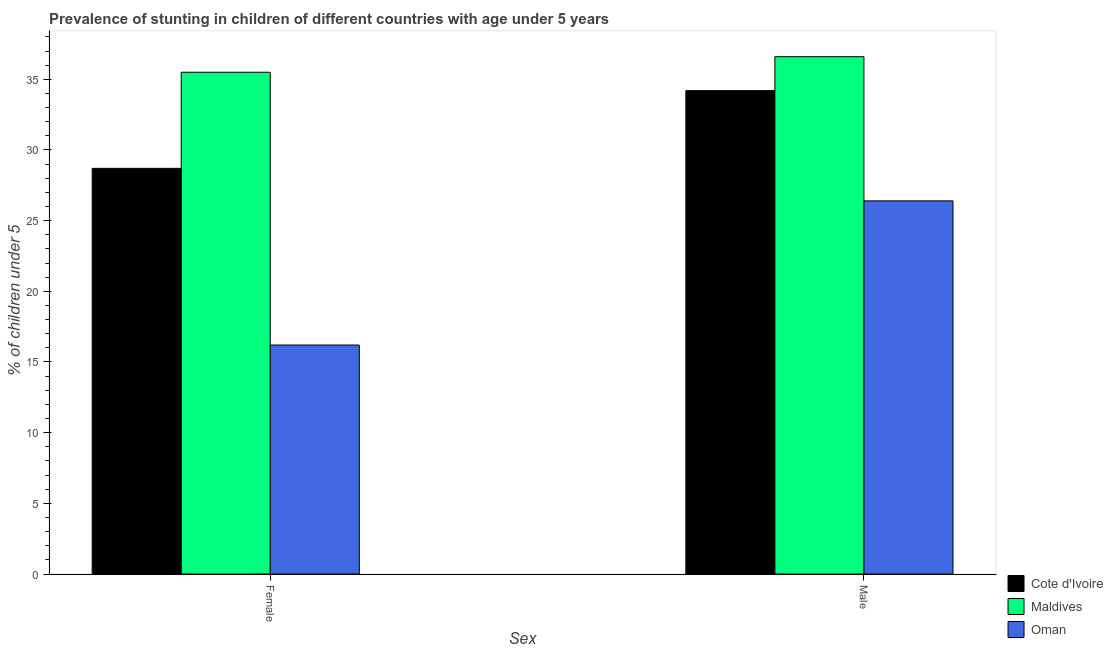How many different coloured bars are there?
Your response must be concise. 3. What is the label of the 2nd group of bars from the left?
Keep it short and to the point. Male. What is the percentage of stunted female children in Cote d'Ivoire?
Offer a terse response. 28.7. Across all countries, what is the maximum percentage of stunted male children?
Your answer should be compact. 36.6. Across all countries, what is the minimum percentage of stunted female children?
Your answer should be compact. 16.2. In which country was the percentage of stunted male children maximum?
Provide a short and direct response. Maldives. In which country was the percentage of stunted female children minimum?
Offer a terse response. Oman. What is the total percentage of stunted male children in the graph?
Your answer should be very brief. 97.2. What is the difference between the percentage of stunted male children in Oman and that in Maldives?
Provide a succinct answer. -10.2. What is the difference between the percentage of stunted male children in Maldives and the percentage of stunted female children in Oman?
Your response must be concise. 20.4. What is the average percentage of stunted female children per country?
Keep it short and to the point. 26.8. What is the difference between the percentage of stunted male children and percentage of stunted female children in Cote d'Ivoire?
Offer a very short reply. 5.5. In how many countries, is the percentage of stunted male children greater than 18 %?
Make the answer very short. 3. What is the ratio of the percentage of stunted male children in Maldives to that in Oman?
Ensure brevity in your answer.  1.39. Is the percentage of stunted female children in Cote d'Ivoire less than that in Maldives?
Make the answer very short. Yes. In how many countries, is the percentage of stunted male children greater than the average percentage of stunted male children taken over all countries?
Ensure brevity in your answer.  2. What does the 2nd bar from the left in Male represents?
Offer a very short reply. Maldives. What does the 1st bar from the right in Female represents?
Offer a very short reply. Oman. How many bars are there?
Your answer should be compact. 6. What is the difference between two consecutive major ticks on the Y-axis?
Your answer should be compact. 5. What is the title of the graph?
Give a very brief answer. Prevalence of stunting in children of different countries with age under 5 years. Does "Libya" appear as one of the legend labels in the graph?
Your answer should be very brief. No. What is the label or title of the X-axis?
Give a very brief answer. Sex. What is the label or title of the Y-axis?
Offer a terse response.  % of children under 5. What is the  % of children under 5 of Cote d'Ivoire in Female?
Offer a terse response. 28.7. What is the  % of children under 5 of Maldives in Female?
Ensure brevity in your answer.  35.5. What is the  % of children under 5 in Oman in Female?
Your answer should be very brief. 16.2. What is the  % of children under 5 of Cote d'Ivoire in Male?
Your response must be concise. 34.2. What is the  % of children under 5 in Maldives in Male?
Provide a succinct answer. 36.6. What is the  % of children under 5 of Oman in Male?
Your response must be concise. 26.4. Across all Sex, what is the maximum  % of children under 5 in Cote d'Ivoire?
Give a very brief answer. 34.2. Across all Sex, what is the maximum  % of children under 5 of Maldives?
Your answer should be compact. 36.6. Across all Sex, what is the maximum  % of children under 5 in Oman?
Provide a succinct answer. 26.4. Across all Sex, what is the minimum  % of children under 5 of Cote d'Ivoire?
Give a very brief answer. 28.7. Across all Sex, what is the minimum  % of children under 5 in Maldives?
Give a very brief answer. 35.5. Across all Sex, what is the minimum  % of children under 5 of Oman?
Make the answer very short. 16.2. What is the total  % of children under 5 of Cote d'Ivoire in the graph?
Offer a terse response. 62.9. What is the total  % of children under 5 of Maldives in the graph?
Ensure brevity in your answer.  72.1. What is the total  % of children under 5 in Oman in the graph?
Your answer should be very brief. 42.6. What is the difference between the  % of children under 5 in Cote d'Ivoire in Female and that in Male?
Your answer should be compact. -5.5. What is the difference between the  % of children under 5 of Maldives in Female and that in Male?
Offer a very short reply. -1.1. What is the difference between the  % of children under 5 of Oman in Female and that in Male?
Keep it short and to the point. -10.2. What is the difference between the  % of children under 5 of Cote d'Ivoire in Female and the  % of children under 5 of Maldives in Male?
Your answer should be compact. -7.9. What is the difference between the  % of children under 5 in Maldives in Female and the  % of children under 5 in Oman in Male?
Provide a succinct answer. 9.1. What is the average  % of children under 5 of Cote d'Ivoire per Sex?
Offer a terse response. 31.45. What is the average  % of children under 5 of Maldives per Sex?
Make the answer very short. 36.05. What is the average  % of children under 5 in Oman per Sex?
Give a very brief answer. 21.3. What is the difference between the  % of children under 5 of Cote d'Ivoire and  % of children under 5 of Maldives in Female?
Keep it short and to the point. -6.8. What is the difference between the  % of children under 5 of Cote d'Ivoire and  % of children under 5 of Oman in Female?
Your answer should be compact. 12.5. What is the difference between the  % of children under 5 in Maldives and  % of children under 5 in Oman in Female?
Your response must be concise. 19.3. What is the difference between the  % of children under 5 of Cote d'Ivoire and  % of children under 5 of Maldives in Male?
Your answer should be compact. -2.4. What is the ratio of the  % of children under 5 of Cote d'Ivoire in Female to that in Male?
Give a very brief answer. 0.84. What is the ratio of the  % of children under 5 in Maldives in Female to that in Male?
Your answer should be very brief. 0.97. What is the ratio of the  % of children under 5 in Oman in Female to that in Male?
Keep it short and to the point. 0.61. What is the difference between the highest and the second highest  % of children under 5 in Cote d'Ivoire?
Provide a short and direct response. 5.5. What is the difference between the highest and the second highest  % of children under 5 in Maldives?
Give a very brief answer. 1.1. What is the difference between the highest and the lowest  % of children under 5 in Cote d'Ivoire?
Provide a succinct answer. 5.5. What is the difference between the highest and the lowest  % of children under 5 in Maldives?
Keep it short and to the point. 1.1. 